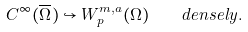<formula> <loc_0><loc_0><loc_500><loc_500>C ^ { \infty } ( { \overline { \Omega } } ) \hookrightarrow W _ { p } ^ { m , a } ( \Omega ) \quad d e n s e l y .</formula> 